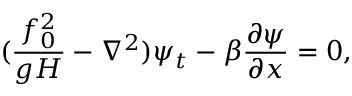Convert formula to latex. <formula><loc_0><loc_0><loc_500><loc_500>( \frac { f _ { 0 } ^ { 2 } } { g H } - \nabla ^ { 2 } ) \psi _ { t } - \beta \frac { \partial \psi } { \partial x } = 0 ,</formula> 